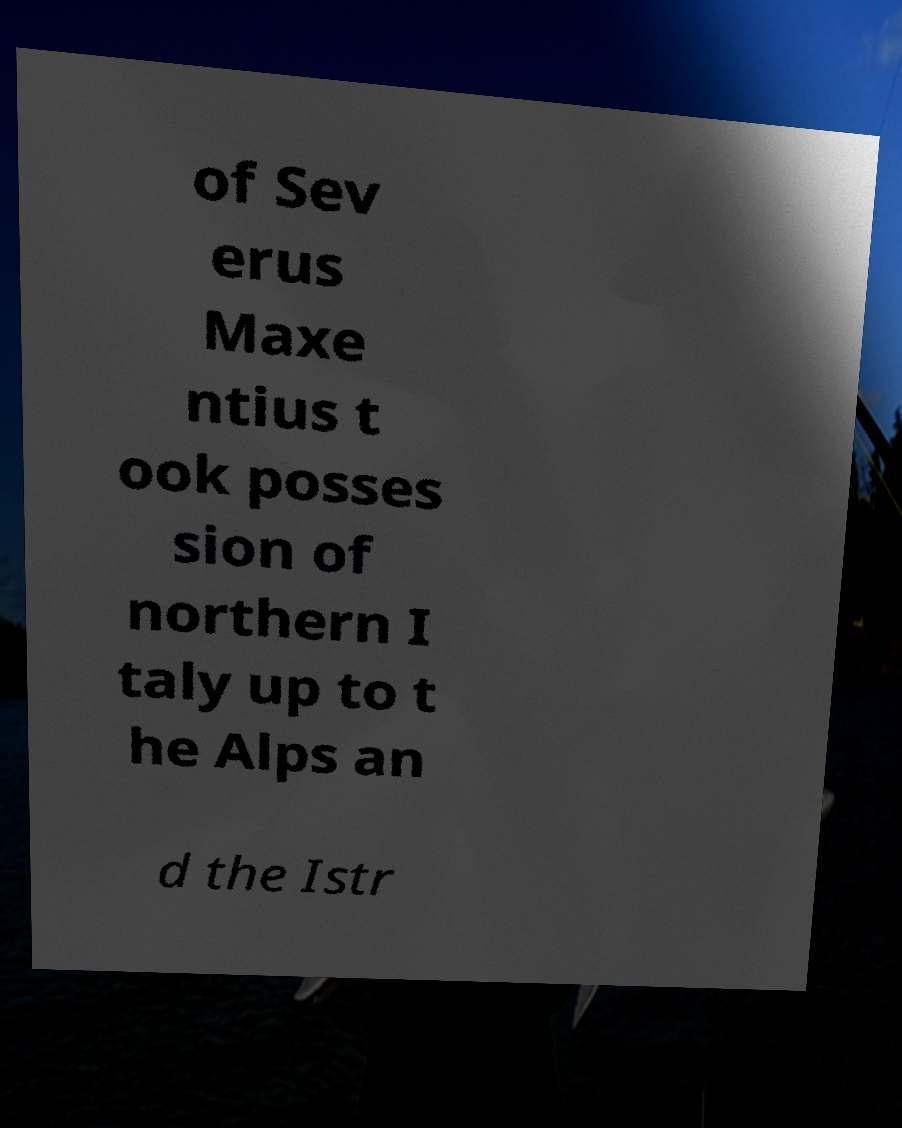Could you assist in decoding the text presented in this image and type it out clearly? of Sev erus Maxe ntius t ook posses sion of northern I taly up to t he Alps an d the Istr 